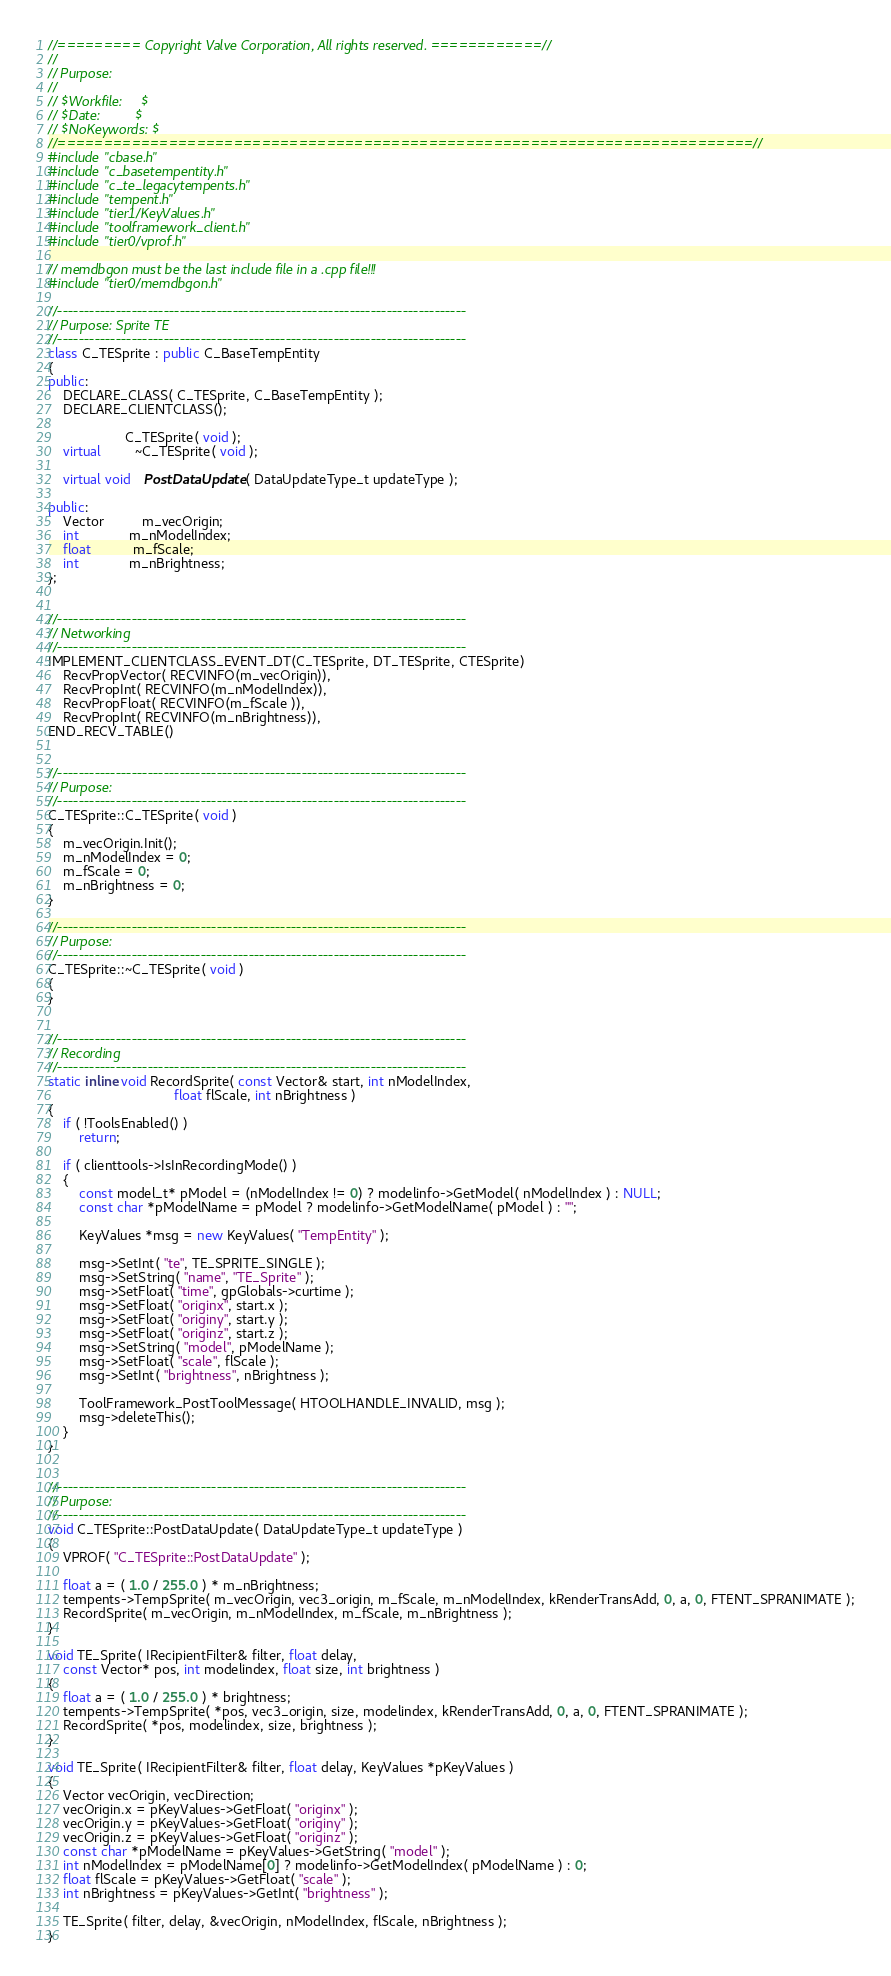<code> <loc_0><loc_0><loc_500><loc_500><_C++_>//========= Copyright Valve Corporation, All rights reserved. ============//
//
// Purpose:
//
// $Workfile:     $
// $Date:         $
// $NoKeywords: $
//===========================================================================//
#include "cbase.h"
#include "c_basetempentity.h"
#include "c_te_legacytempents.h"
#include "tempent.h"
#include "tier1/KeyValues.h"
#include "toolframework_client.h"
#include "tier0/vprof.h"

// memdbgon must be the last include file in a .cpp file!!!
#include "tier0/memdbgon.h"

//-----------------------------------------------------------------------------
// Purpose: Sprite TE
//-----------------------------------------------------------------------------
class C_TESprite : public C_BaseTempEntity
{
public:
    DECLARE_CLASS( C_TESprite, C_BaseTempEntity );
    DECLARE_CLIENTCLASS();

                    C_TESprite( void );
    virtual         ~C_TESprite( void );

    virtual void    PostDataUpdate( DataUpdateType_t updateType );

public:
    Vector          m_vecOrigin;
    int             m_nModelIndex;
    float           m_fScale;
    int             m_nBrightness;
};


//-----------------------------------------------------------------------------
// Networking
//-----------------------------------------------------------------------------
IMPLEMENT_CLIENTCLASS_EVENT_DT(C_TESprite, DT_TESprite, CTESprite)
    RecvPropVector( RECVINFO(m_vecOrigin)),
    RecvPropInt( RECVINFO(m_nModelIndex)),
    RecvPropFloat( RECVINFO(m_fScale )),
    RecvPropInt( RECVINFO(m_nBrightness)),
END_RECV_TABLE()


//-----------------------------------------------------------------------------
// Purpose:
//-----------------------------------------------------------------------------
C_TESprite::C_TESprite( void )
{
    m_vecOrigin.Init();
    m_nModelIndex = 0;
    m_fScale = 0;
    m_nBrightness = 0;
}

//-----------------------------------------------------------------------------
// Purpose:
//-----------------------------------------------------------------------------
C_TESprite::~C_TESprite( void )
{
}


//-----------------------------------------------------------------------------
// Recording
//-----------------------------------------------------------------------------
static inline void RecordSprite( const Vector& start, int nModelIndex,
                                 float flScale, int nBrightness )
{
    if ( !ToolsEnabled() )
        return;

    if ( clienttools->IsInRecordingMode() )
    {
        const model_t* pModel = (nModelIndex != 0) ? modelinfo->GetModel( nModelIndex ) : NULL;
        const char *pModelName = pModel ? modelinfo->GetModelName( pModel ) : "";

        KeyValues *msg = new KeyValues( "TempEntity" );

        msg->SetInt( "te", TE_SPRITE_SINGLE );
        msg->SetString( "name", "TE_Sprite" );
        msg->SetFloat( "time", gpGlobals->curtime );
        msg->SetFloat( "originx", start.x );
        msg->SetFloat( "originy", start.y );
        msg->SetFloat( "originz", start.z );
        msg->SetString( "model", pModelName );
        msg->SetFloat( "scale", flScale );
        msg->SetInt( "brightness", nBrightness );

        ToolFramework_PostToolMessage( HTOOLHANDLE_INVALID, msg );
        msg->deleteThis();
    }
}


//-----------------------------------------------------------------------------
// Purpose:
//-----------------------------------------------------------------------------
void C_TESprite::PostDataUpdate( DataUpdateType_t updateType )
{
    VPROF( "C_TESprite::PostDataUpdate" );

    float a = ( 1.0 / 255.0 ) * m_nBrightness;
    tempents->TempSprite( m_vecOrigin, vec3_origin, m_fScale, m_nModelIndex, kRenderTransAdd, 0, a, 0, FTENT_SPRANIMATE );
    RecordSprite( m_vecOrigin, m_nModelIndex, m_fScale, m_nBrightness );
}

void TE_Sprite( IRecipientFilter& filter, float delay,
    const Vector* pos, int modelindex, float size, int brightness )
{
    float a = ( 1.0 / 255.0 ) * brightness;
    tempents->TempSprite( *pos, vec3_origin, size, modelindex, kRenderTransAdd, 0, a, 0, FTENT_SPRANIMATE );
    RecordSprite( *pos, modelindex, size, brightness );
}

void TE_Sprite( IRecipientFilter& filter, float delay, KeyValues *pKeyValues )
{
    Vector vecOrigin, vecDirection;
    vecOrigin.x = pKeyValues->GetFloat( "originx" );
    vecOrigin.y = pKeyValues->GetFloat( "originy" );
    vecOrigin.z = pKeyValues->GetFloat( "originz" );
    const char *pModelName = pKeyValues->GetString( "model" );
    int nModelIndex = pModelName[0] ? modelinfo->GetModelIndex( pModelName ) : 0;
    float flScale = pKeyValues->GetFloat( "scale" );
    int nBrightness = pKeyValues->GetInt( "brightness" );

    TE_Sprite( filter, delay, &vecOrigin, nModelIndex, flScale, nBrightness );
}
</code> 